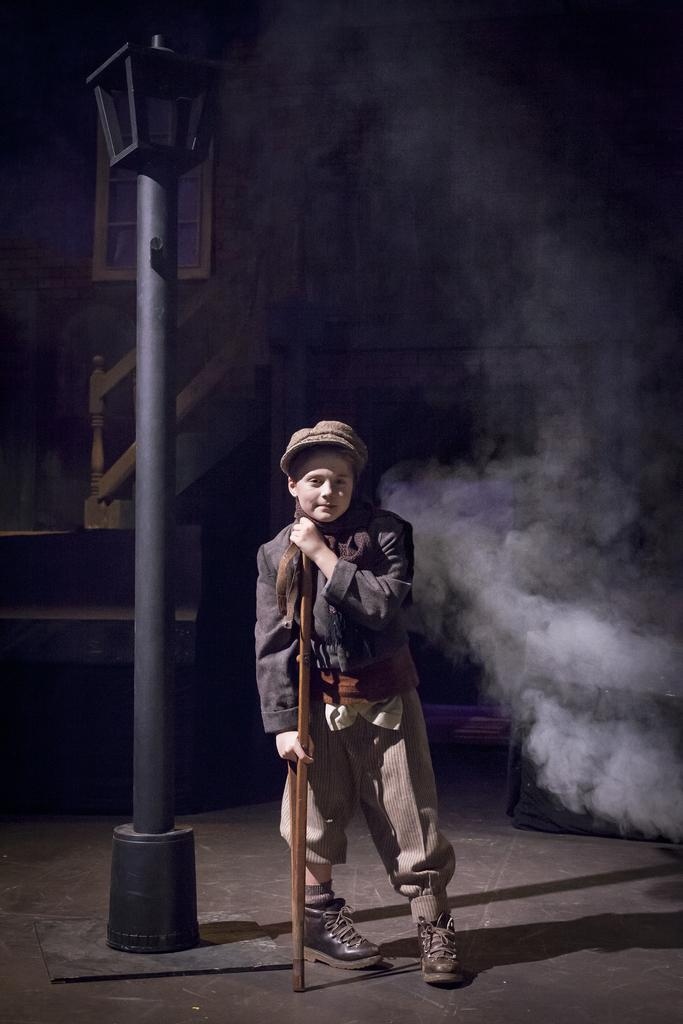What is the main subject of the image? There is a child in the image. What is the child doing in the image? The child is standing on the ground and holding a stick. What can be seen in the background of the image? There is a street lamp on a pole and a building with windows in the image. Can you describe the building in the image? The building has windows and stairs. What type of garden can be seen in the image? There is no garden present in the image. What behavior is the child exhibiting in the image? The provided facts do not mention any specific behavior of the child; we only know that the child is standing on the ground and holding a stick. 